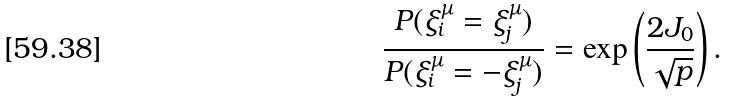<formula> <loc_0><loc_0><loc_500><loc_500>\frac { P ( \xi _ { i } ^ { \mu } = \xi _ { j } ^ { \mu } ) } { P ( \xi _ { i } ^ { \mu } = - \xi _ { j } ^ { \mu } ) } = \exp \left ( \frac { 2 J _ { 0 } } { \sqrt { p } } \right ) .</formula> 